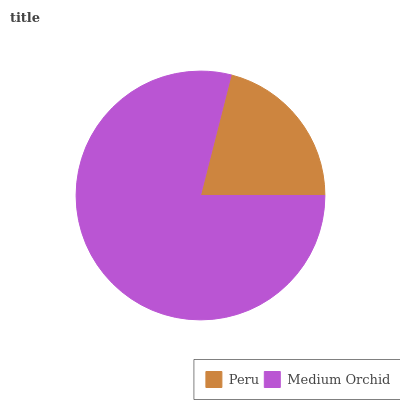Is Peru the minimum?
Answer yes or no. Yes. Is Medium Orchid the maximum?
Answer yes or no. Yes. Is Medium Orchid the minimum?
Answer yes or no. No. Is Medium Orchid greater than Peru?
Answer yes or no. Yes. Is Peru less than Medium Orchid?
Answer yes or no. Yes. Is Peru greater than Medium Orchid?
Answer yes or no. No. Is Medium Orchid less than Peru?
Answer yes or no. No. Is Medium Orchid the high median?
Answer yes or no. Yes. Is Peru the low median?
Answer yes or no. Yes. Is Peru the high median?
Answer yes or no. No. Is Medium Orchid the low median?
Answer yes or no. No. 